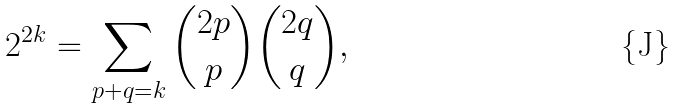<formula> <loc_0><loc_0><loc_500><loc_500>2 ^ { 2 k } = \sum _ { p + q = k } \binom { 2 p } { p } \binom { 2 q } { q } ,</formula> 